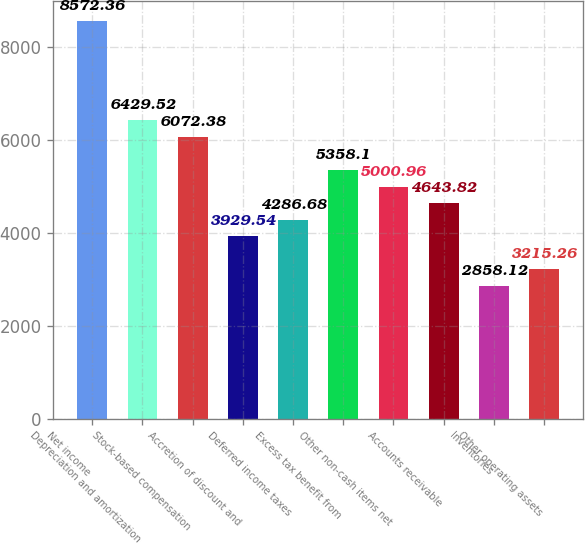Convert chart. <chart><loc_0><loc_0><loc_500><loc_500><bar_chart><fcel>Net income<fcel>Depreciation and amortization<fcel>Stock-based compensation<fcel>Accretion of discount and<fcel>Deferred income taxes<fcel>Excess tax benefit from<fcel>Other non-cash items net<fcel>Accounts receivable<fcel>Inventories<fcel>Other operating assets<nl><fcel>8572.36<fcel>6429.52<fcel>6072.38<fcel>3929.54<fcel>4286.68<fcel>5358.1<fcel>5000.96<fcel>4643.82<fcel>2858.12<fcel>3215.26<nl></chart> 